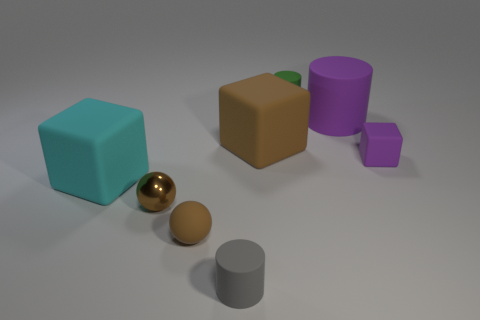How many other objects are the same size as the purple block?
Offer a terse response. 4. Are the tiny gray cylinder and the purple cube made of the same material?
Offer a very short reply. Yes. There is a large rubber cylinder right of the small cylinder that is in front of the green matte cylinder; what color is it?
Keep it short and to the point. Purple. There is a matte object that is the same shape as the tiny brown metallic object; what size is it?
Your answer should be very brief. Small. Is the color of the metallic thing the same as the rubber sphere?
Provide a succinct answer. Yes. How many large brown rubber blocks are in front of the tiny rubber cylinder left of the tiny rubber cylinder that is behind the brown cube?
Your answer should be compact. 0. Is the number of purple blocks greater than the number of large green rubber blocks?
Offer a terse response. Yes. How many cyan matte things are there?
Your answer should be very brief. 1. There is a brown thing that is on the right side of the tiny cylinder in front of the purple cylinder in front of the tiny green thing; what is its shape?
Your response must be concise. Cube. Are there fewer green matte objects that are in front of the cyan matte object than tiny green matte things right of the purple cylinder?
Make the answer very short. No. 